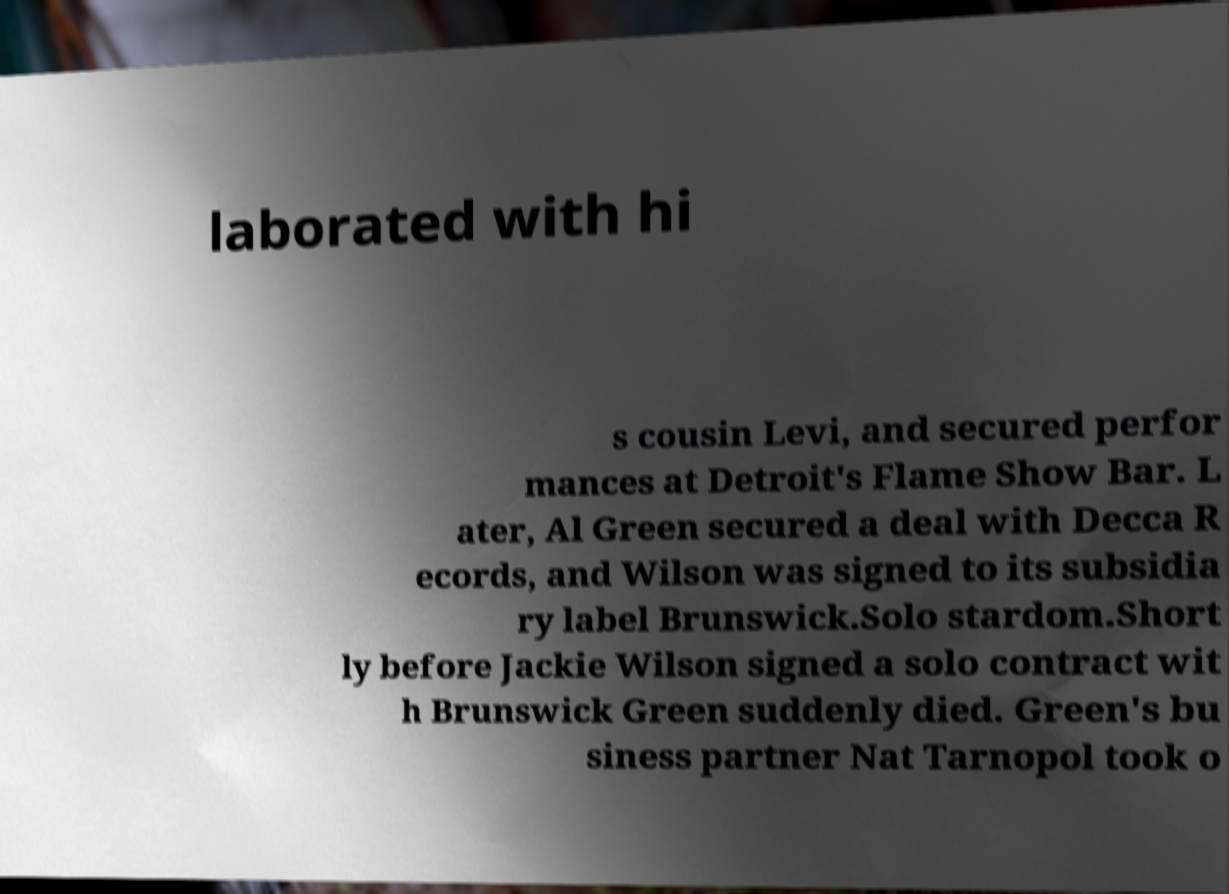Can you read and provide the text displayed in the image?This photo seems to have some interesting text. Can you extract and type it out for me? laborated with hi s cousin Levi, and secured perfor mances at Detroit's Flame Show Bar. L ater, Al Green secured a deal with Decca R ecords, and Wilson was signed to its subsidia ry label Brunswick.Solo stardom.Short ly before Jackie Wilson signed a solo contract wit h Brunswick Green suddenly died. Green's bu siness partner Nat Tarnopol took o 